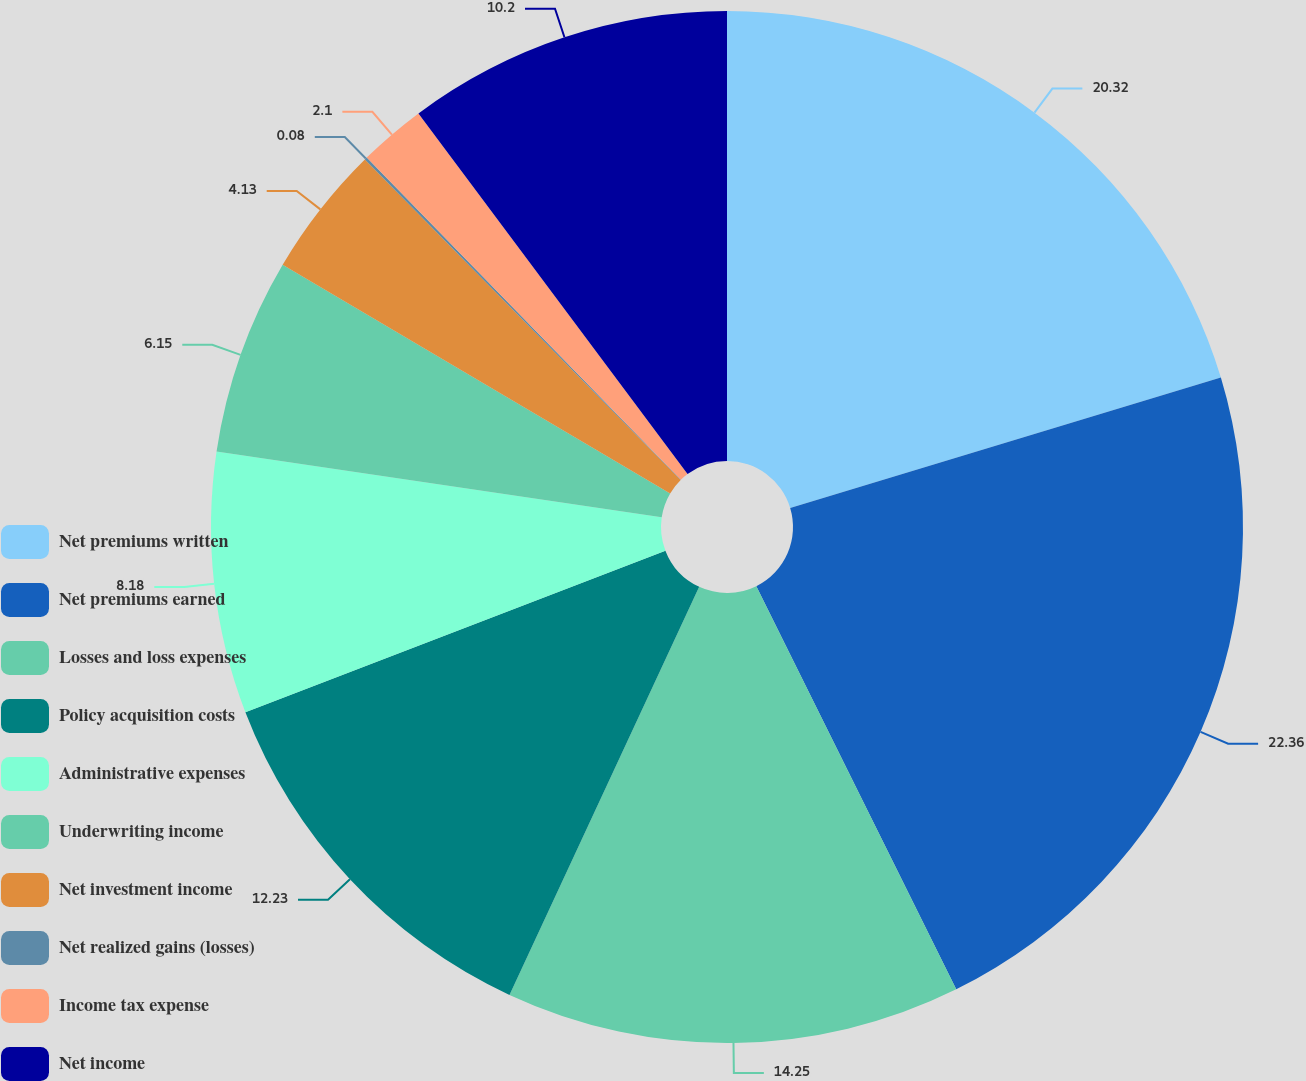Convert chart. <chart><loc_0><loc_0><loc_500><loc_500><pie_chart><fcel>Net premiums written<fcel>Net premiums earned<fcel>Losses and loss expenses<fcel>Policy acquisition costs<fcel>Administrative expenses<fcel>Underwriting income<fcel>Net investment income<fcel>Net realized gains (losses)<fcel>Income tax expense<fcel>Net income<nl><fcel>20.32%<fcel>22.35%<fcel>14.25%<fcel>12.23%<fcel>8.18%<fcel>6.15%<fcel>4.13%<fcel>0.08%<fcel>2.1%<fcel>10.2%<nl></chart> 